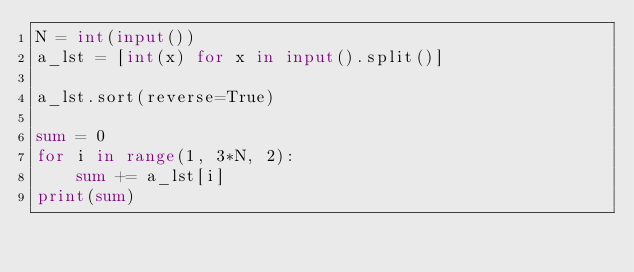<code> <loc_0><loc_0><loc_500><loc_500><_Python_>N = int(input())
a_lst = [int(x) for x in input().split()]

a_lst.sort(reverse=True)

sum = 0
for i in range(1, 3*N, 2):
    sum += a_lst[i]
print(sum)
</code> 